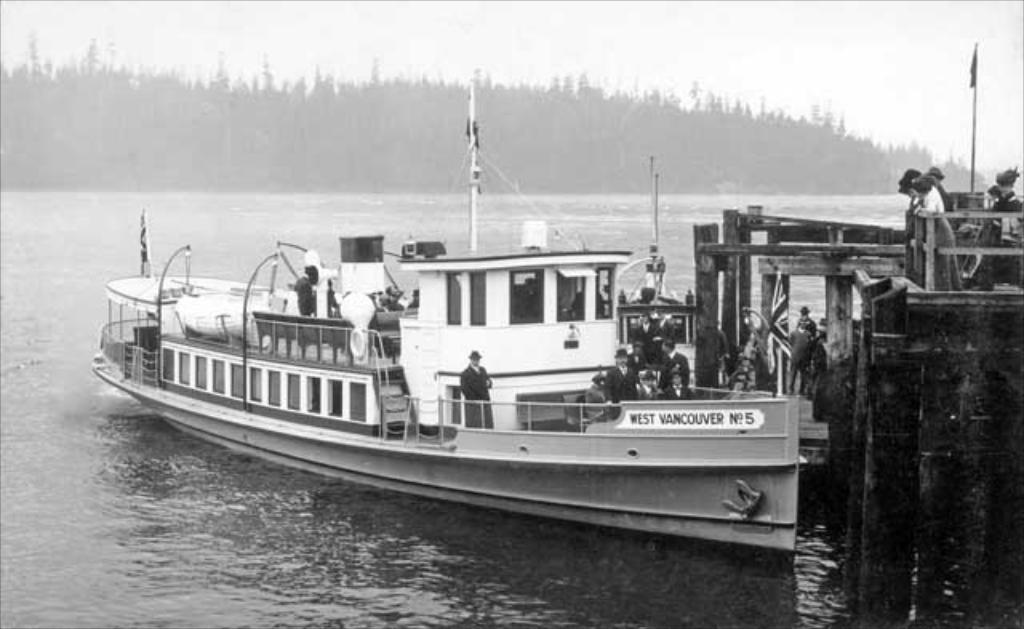<image>
Provide a brief description of the given image. The West Vancouver No 5 is docked at the pier. 